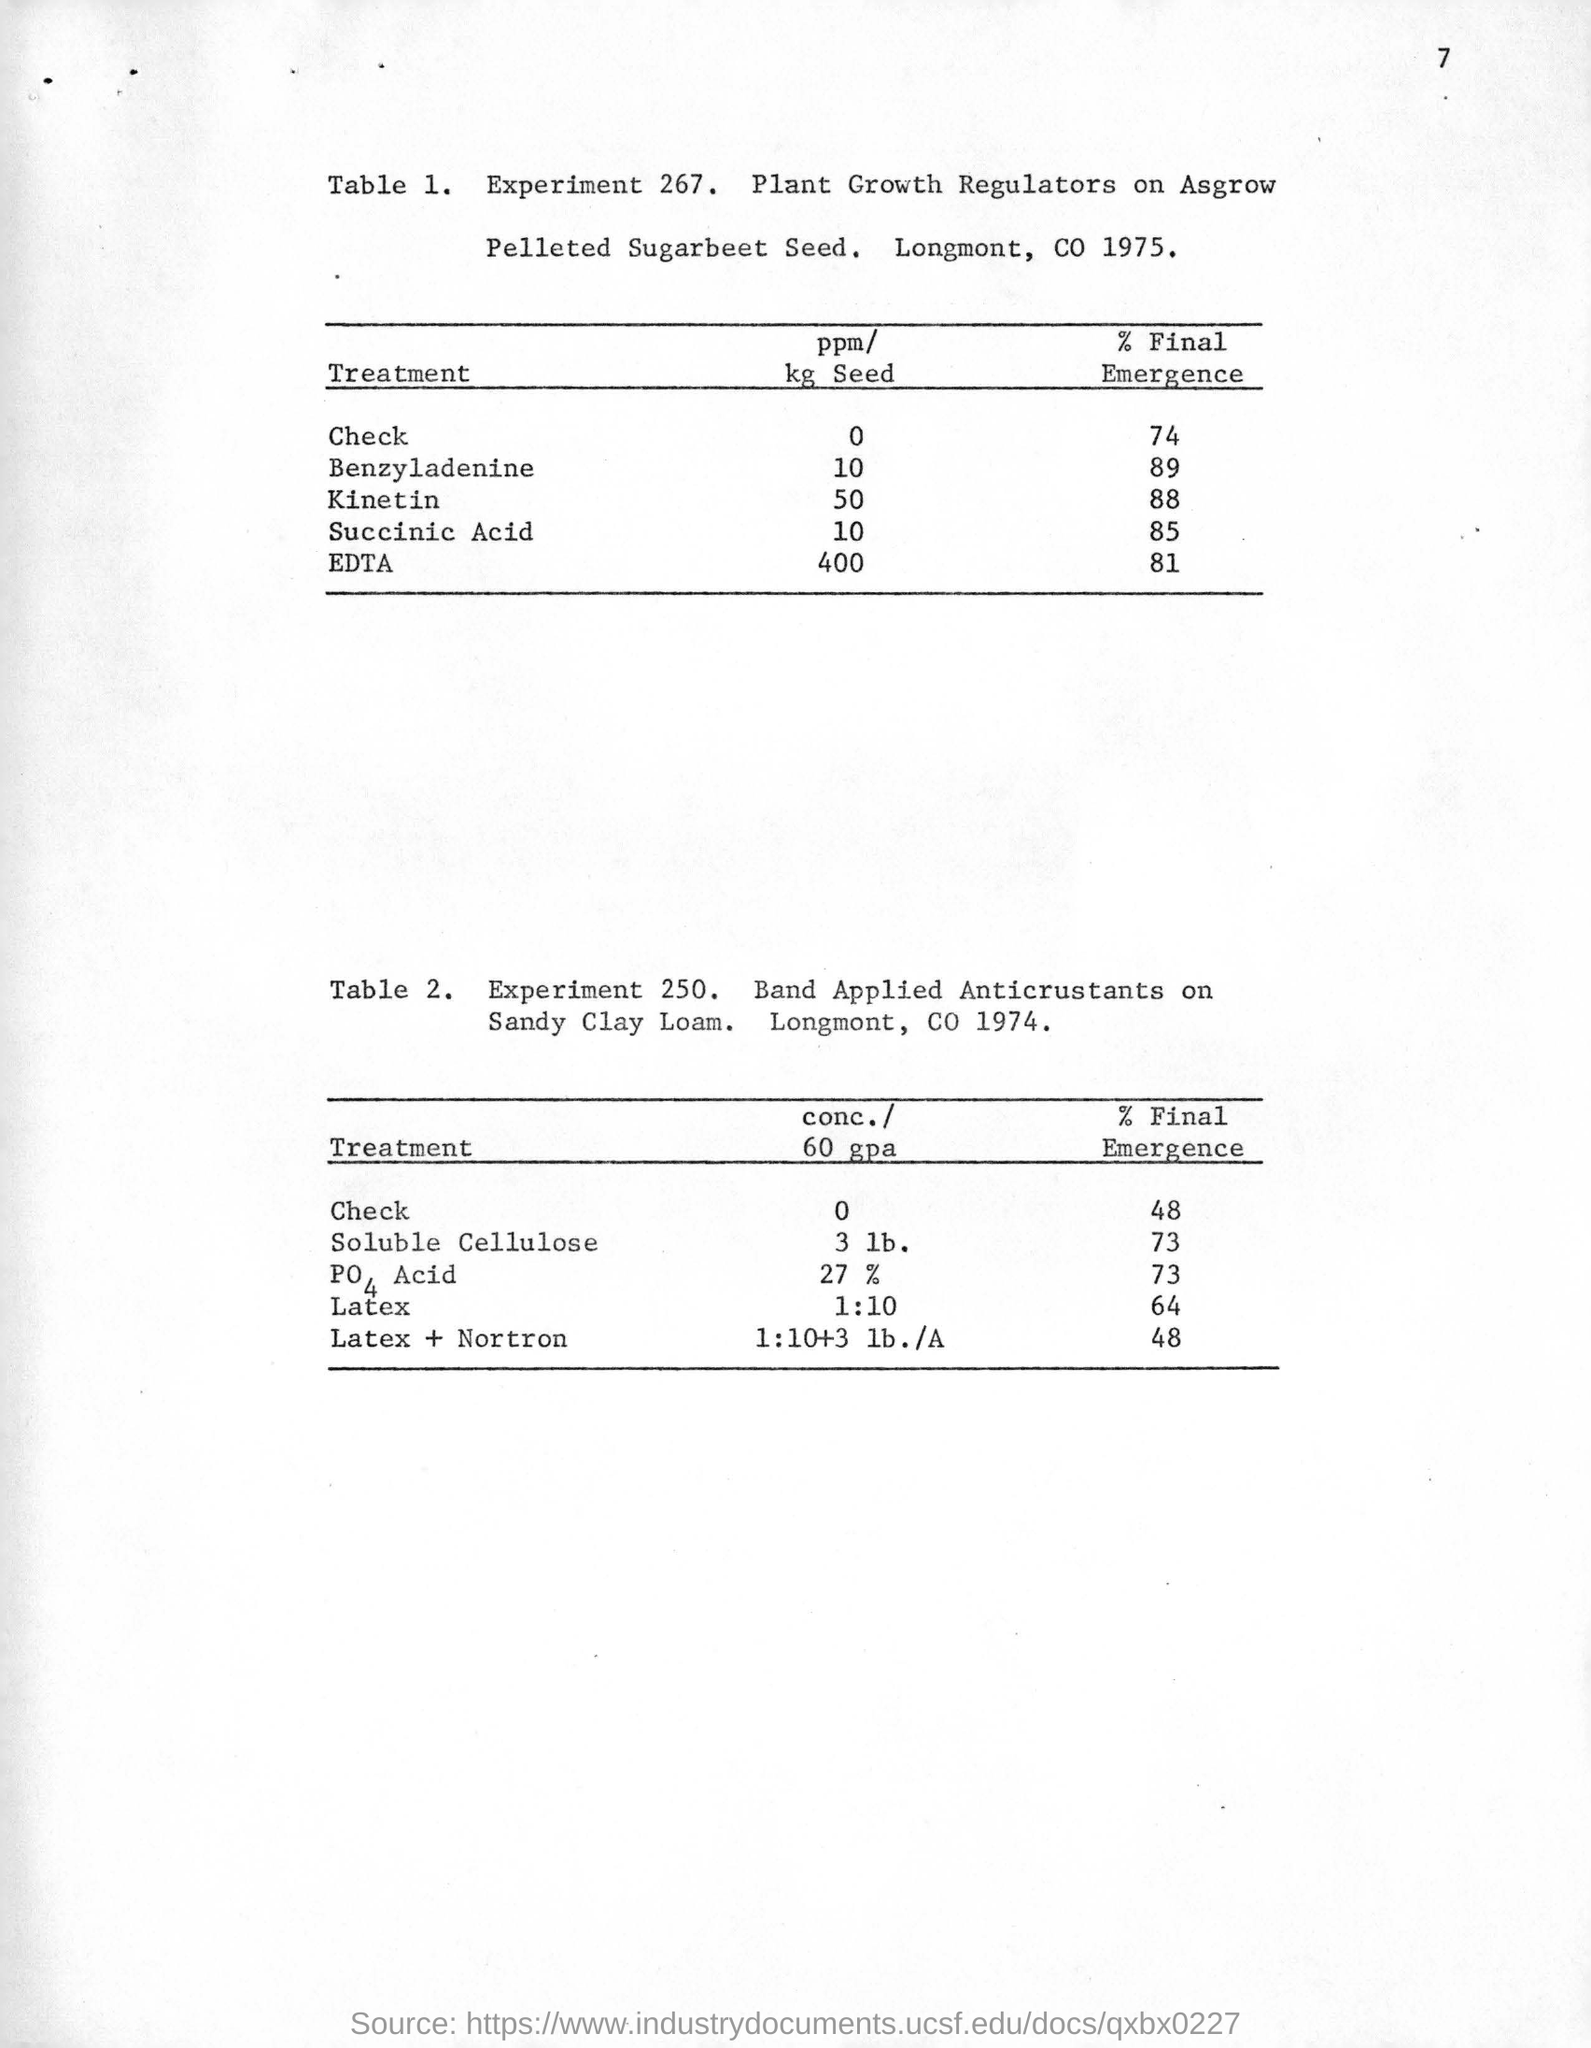Point out several critical features in this image. EDTA is the recommended treatment for soybeans with a Hagberg falling number of 400 ppm/kg. The specified experiment, which is indicated in Table 1 as "Experiment 267," is depicted in the referenced table. The final emergence percentage for EDTA treatment at a seed application rate of 400 ppm/kg is expected to be 81%. 